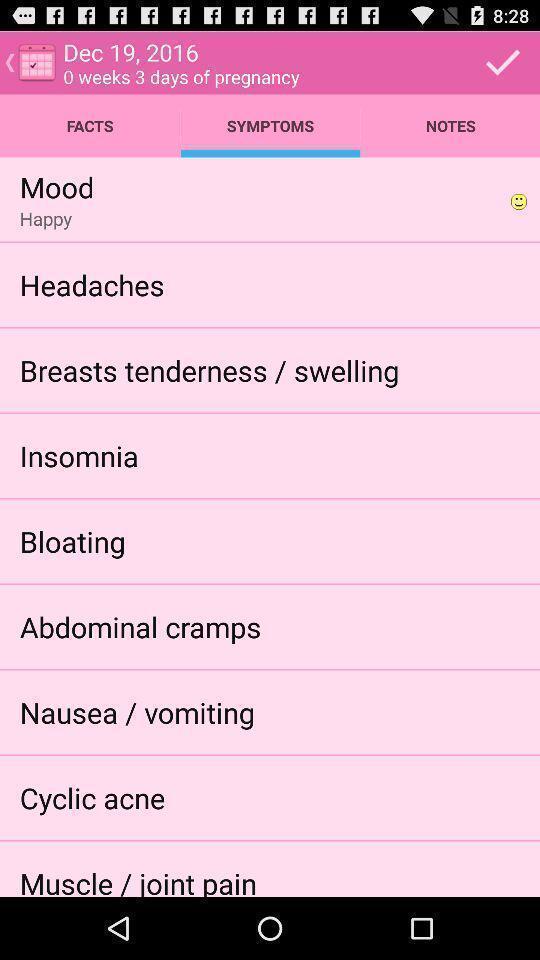Give me a narrative description of this picture. Screen shows symptoms of pregnancy. 